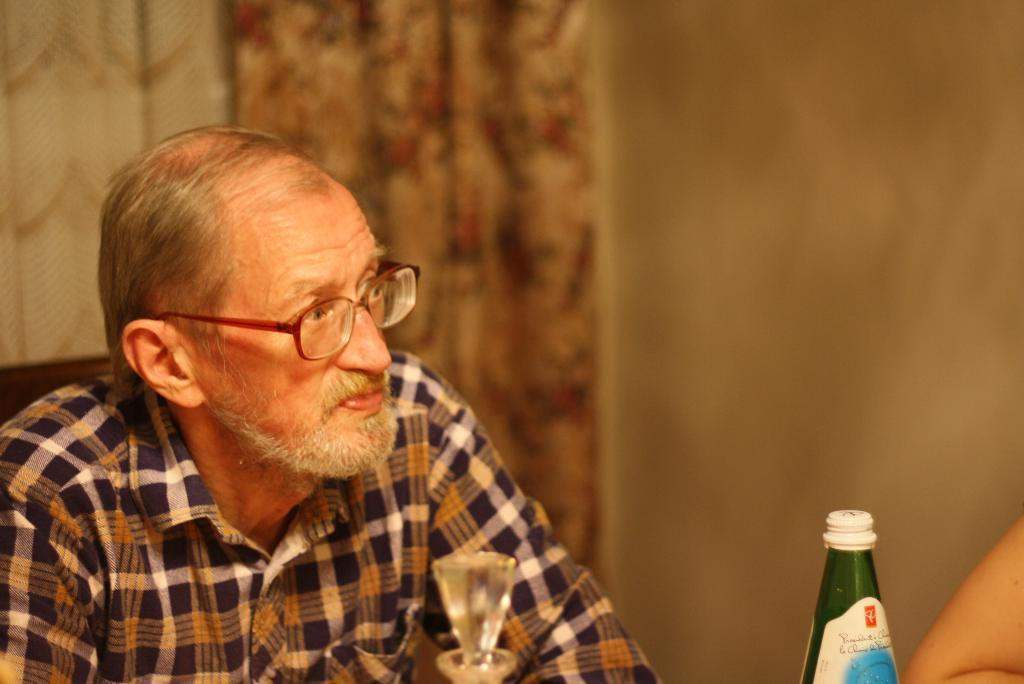What is the man in the image doing? The man is sitting on a chair in the image. Can you describe the man's appearance? The man is wearing spectacles. What object is in front of the man? There is a bottle in front of the man. Who is present in front of the man? There is another person in front of the man. What can be seen in the background of the image? There is a wall in the background of the image. What type of meal is being prepared by the man in the image? There is no indication in the image that the man is preparing a meal, as there are no cooking utensils or ingredients visible. 